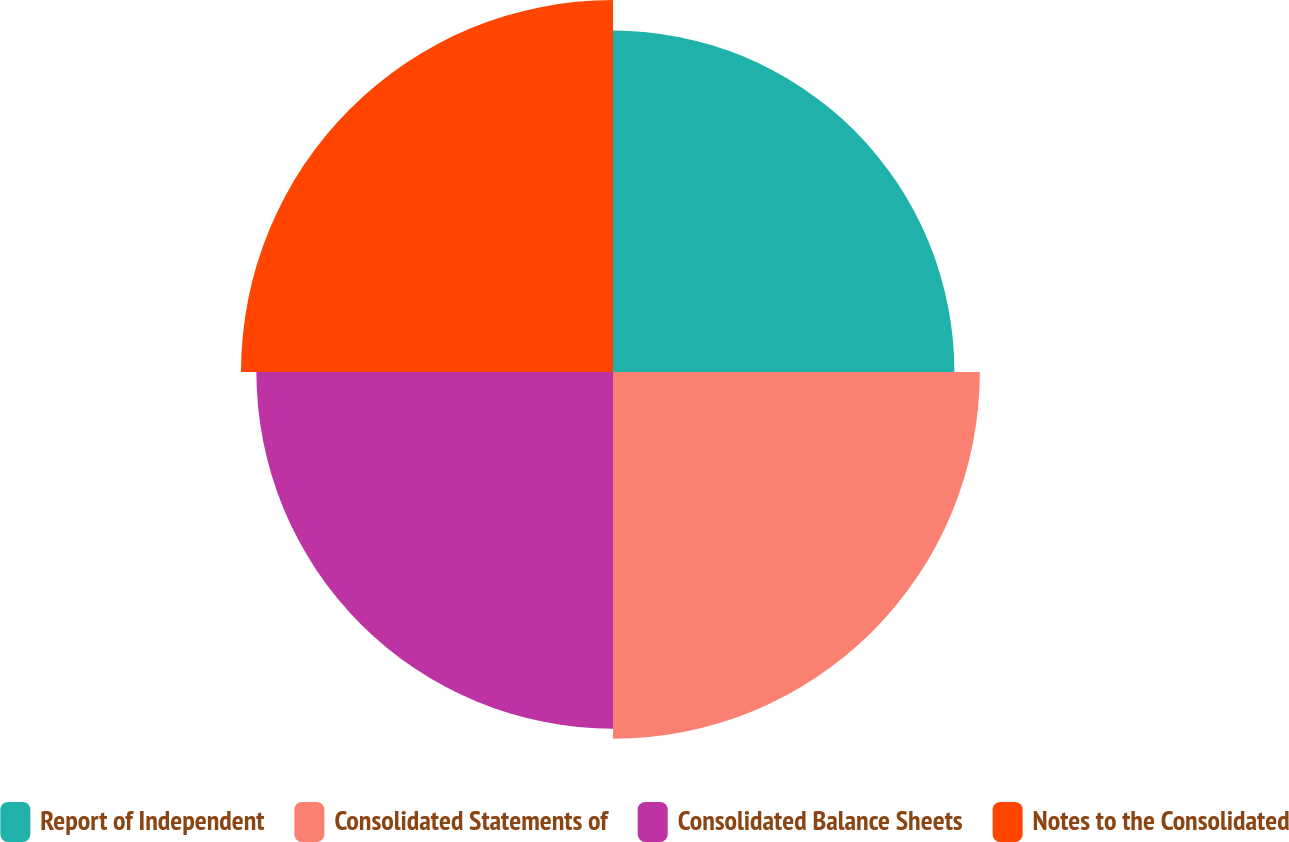Convert chart. <chart><loc_0><loc_0><loc_500><loc_500><pie_chart><fcel>Report of Independent<fcel>Consolidated Statements of<fcel>Consolidated Balance Sheets<fcel>Notes to the Consolidated<nl><fcel>23.76%<fcel>25.53%<fcel>24.82%<fcel>25.89%<nl></chart> 